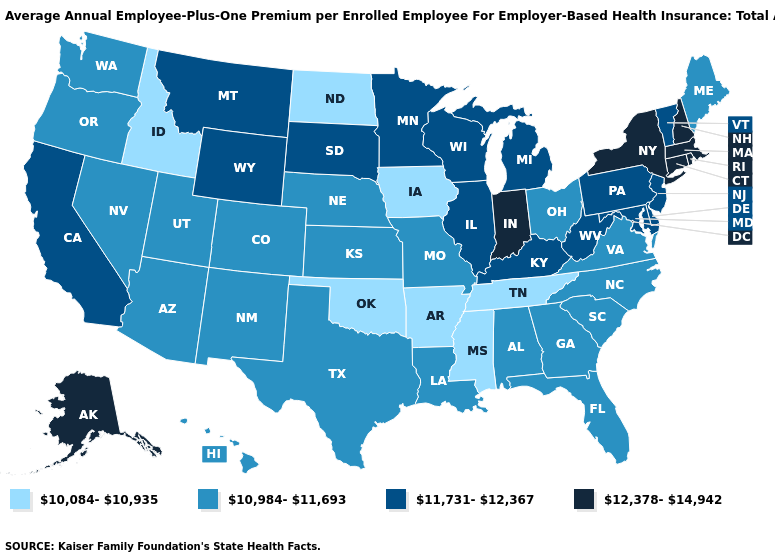Name the states that have a value in the range 10,084-10,935?
Keep it brief. Arkansas, Idaho, Iowa, Mississippi, North Dakota, Oklahoma, Tennessee. Does Ohio have the highest value in the USA?
Concise answer only. No. What is the highest value in the USA?
Be succinct. 12,378-14,942. Does the first symbol in the legend represent the smallest category?
Concise answer only. Yes. What is the value of Virginia?
Answer briefly. 10,984-11,693. Name the states that have a value in the range 12,378-14,942?
Concise answer only. Alaska, Connecticut, Indiana, Massachusetts, New Hampshire, New York, Rhode Island. Among the states that border New Jersey , does Pennsylvania have the highest value?
Quick response, please. No. Which states have the lowest value in the USA?
Concise answer only. Arkansas, Idaho, Iowa, Mississippi, North Dakota, Oklahoma, Tennessee. What is the value of Ohio?
Keep it brief. 10,984-11,693. Does Vermont have the lowest value in the USA?
Short answer required. No. Name the states that have a value in the range 10,084-10,935?
Answer briefly. Arkansas, Idaho, Iowa, Mississippi, North Dakota, Oklahoma, Tennessee. Does Maryland have the same value as Massachusetts?
Concise answer only. No. Name the states that have a value in the range 11,731-12,367?
Short answer required. California, Delaware, Illinois, Kentucky, Maryland, Michigan, Minnesota, Montana, New Jersey, Pennsylvania, South Dakota, Vermont, West Virginia, Wisconsin, Wyoming. What is the value of New Mexico?
Short answer required. 10,984-11,693. Name the states that have a value in the range 11,731-12,367?
Write a very short answer. California, Delaware, Illinois, Kentucky, Maryland, Michigan, Minnesota, Montana, New Jersey, Pennsylvania, South Dakota, Vermont, West Virginia, Wisconsin, Wyoming. 